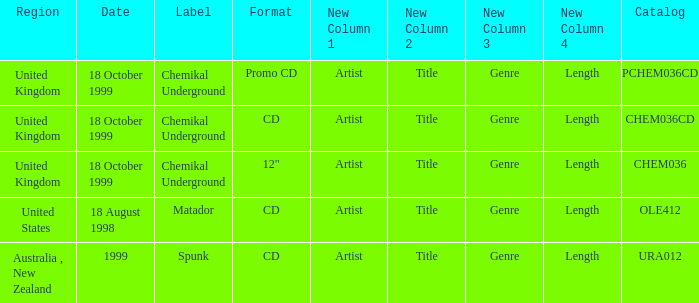What label is associated with the United Kingdom and the chem036 catalog? Chemikal Underground. 